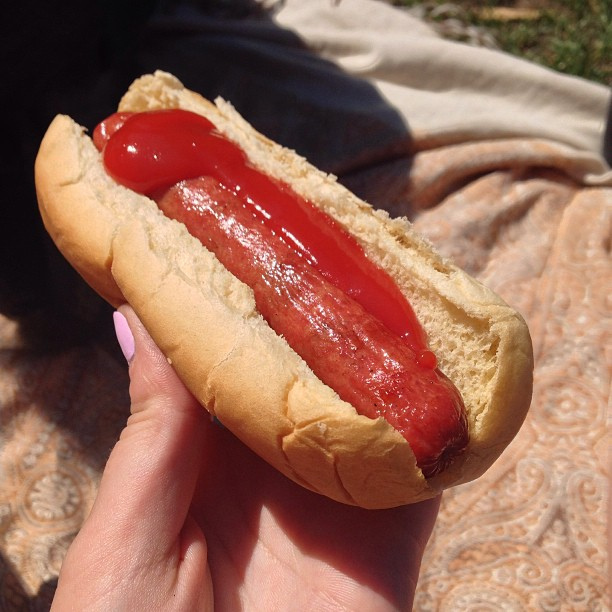<image>Is it a man or woman holding the hot dog? I am not sure if it is a man or woman holding the hot dog. It can be a woman. Is it a man or woman holding the hot dog? I am not sure if it is a man or woman holding the hot dog. But it seems like a woman. 